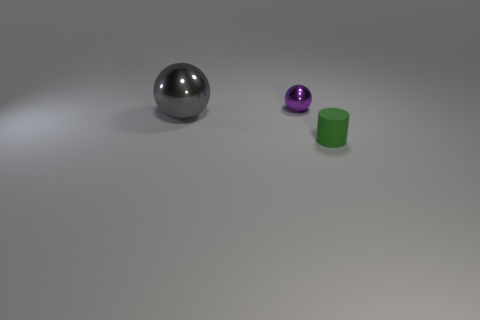Subtract all brown cylinders. Subtract all cyan spheres. How many cylinders are left? 1 Add 3 big cyan rubber balls. How many objects exist? 6 Subtract all spheres. How many objects are left? 1 Subtract 0 green blocks. How many objects are left? 3 Subtract all small purple metallic objects. Subtract all gray shiny spheres. How many objects are left? 1 Add 2 small shiny spheres. How many small shiny spheres are left? 3 Add 3 small cyan metal cylinders. How many small cyan metal cylinders exist? 3 